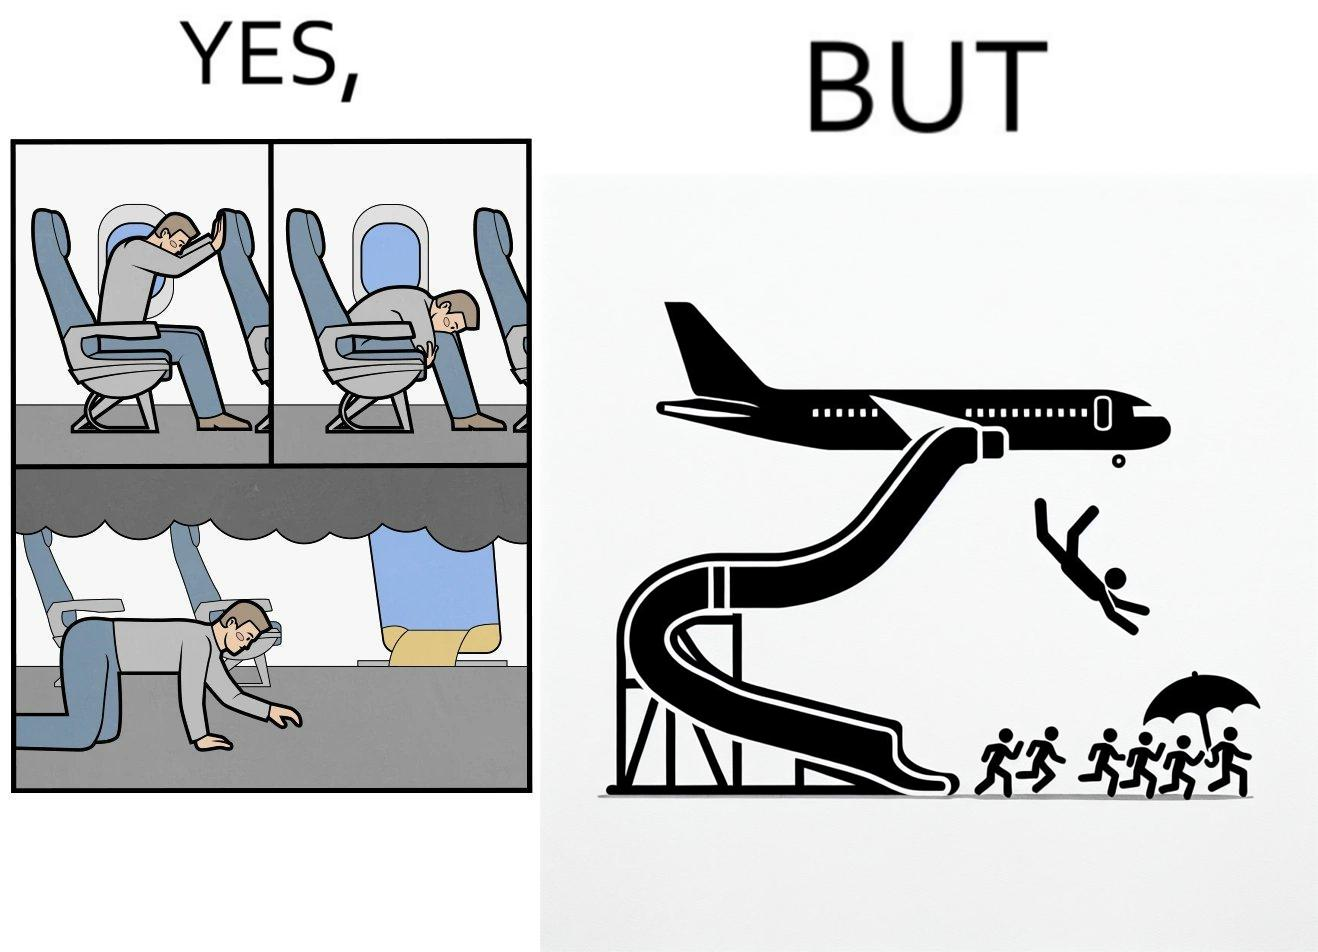What does this image depict? These images are funny since it shows how we are taught emergency procedures to follow in case of an accident while in an airplane but how none of them work if the plane is still in air 